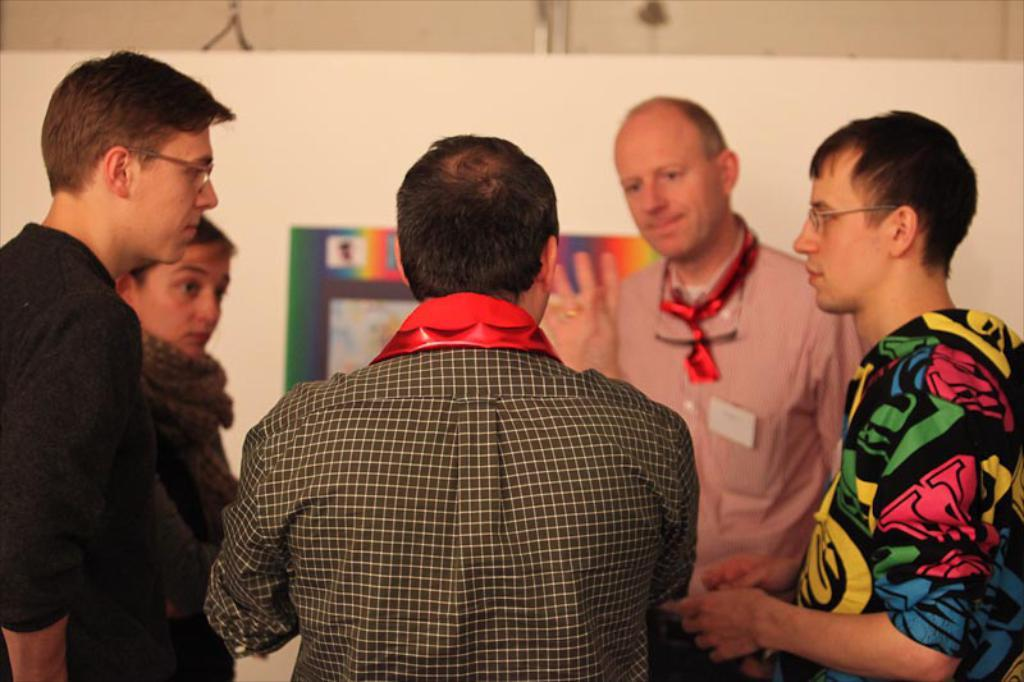What are the people in the image doing? The persons in the image are standing in a circle. How would you describe the background of the image? The background of the image is slightly blurred. What can be seen in the background of the image? There is a board and a wall visible in the background of the image. What type of hair is visible on the board in the image? There is no hair visible on the board in the image. How does the board contribute to the peace in the image? The board does not contribute to peace in the image, as it is simply an object in the background. 